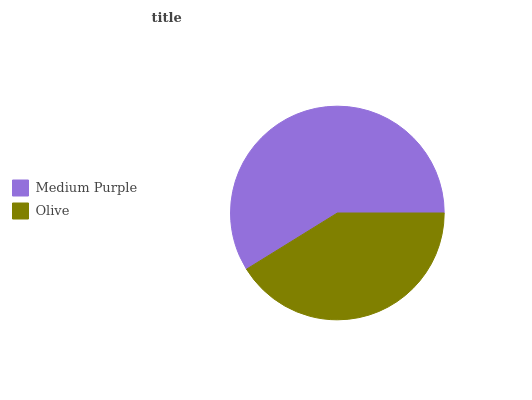Is Olive the minimum?
Answer yes or no. Yes. Is Medium Purple the maximum?
Answer yes or no. Yes. Is Olive the maximum?
Answer yes or no. No. Is Medium Purple greater than Olive?
Answer yes or no. Yes. Is Olive less than Medium Purple?
Answer yes or no. Yes. Is Olive greater than Medium Purple?
Answer yes or no. No. Is Medium Purple less than Olive?
Answer yes or no. No. Is Medium Purple the high median?
Answer yes or no. Yes. Is Olive the low median?
Answer yes or no. Yes. Is Olive the high median?
Answer yes or no. No. Is Medium Purple the low median?
Answer yes or no. No. 